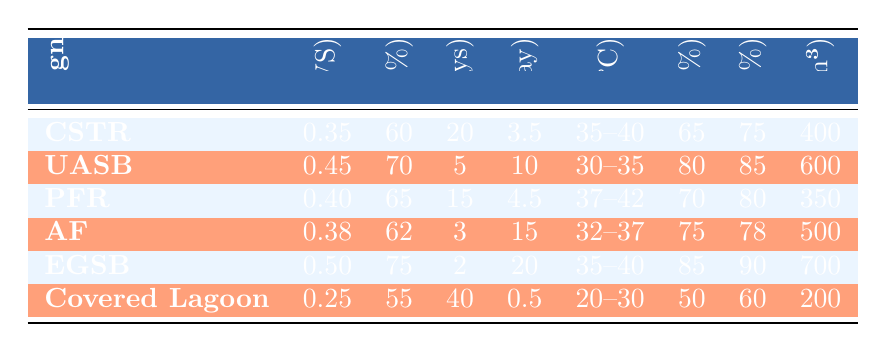What is the highest biogas yield reported in the table? The biogas yield values are provided in the second column. By reviewing the values, 0.50 m³/kg VS is the highest, which corresponds to the Expanded Granular Sludge Bed (EGSB) design.
Answer: 0.50 m³/kg VS Which digester design has the lowest capital cost per cubic meter? The capital costs are listed in the last column. The Covered Lagoon has the lowest cost at $200/m³.
Answer: $200/m³ Is the methane content in the Anaerobic Filter higher than in the Continuous Stirred Tank Reactor? The methane content for the Anaerobic Filter is 62%, and for the Continuous Stirred Tank Reactor (CSTR), it is 60%. Since 62% is greater than 60%, the statement is true.
Answer: Yes What is the average Hydraulic Retention Time (HRT) of all the digesters in the table? The HRT values are: 20, 5, 15, 3, 2, and 40 days. Summing these gives 85 days, and there are 6 designs, so the average is 85/6 = 14.17 days.
Answer: 14.17 days Which design exhibits the highest Energy Efficiency, and what is that value? Reviewing the Energy Efficiency column, the highest value is 90%, which belongs to the Expanded Granular Sludge Bed (EGSB) design.
Answer: 90% How much higher is the OLR of the EGSB compared to the Covered Lagoon? The OLR for EGSB is 20 kg VS/m³/day, and for the Covered Lagoon, it is 0.5 kg VS/m³/day. The difference is 20 - 0.5 = 19.5 kg VS/m³/day.
Answer: 19.5 kg VS/m³/day Does the Upflow Anaerobic Sludge Blanket (UASB) design have a higher COD removal percentage than the Plug Flow Reactor (PFR)? The COD removal for UASB is 80%, while for PFR it is 70%. Since 80% is greater than 70%, the answer is yes.
Answer: Yes Which digester design has the widest temperature range and what is that range? The temperature ranges for all designs are: CSTR (35-40), UASB (30-35), PFR (37-42), AF (32-37), EGSB (35-40), Covered Lagoon (20-30). PFR has the range of 37-42 °C, which is the widest.
Answer: 37-42 °C What is the average biogas yield of all the digester designs in the table? The biogas yields are: 0.35, 0.45, 0.40, 0.38, 0.50, and 0.25 m³/kg VS. Summing these results gives 2.33 m³/kg VS and dividing by 6 gives an average of approximately 0.39 m³/kg VS.
Answer: 0.39 m³/kg VS 